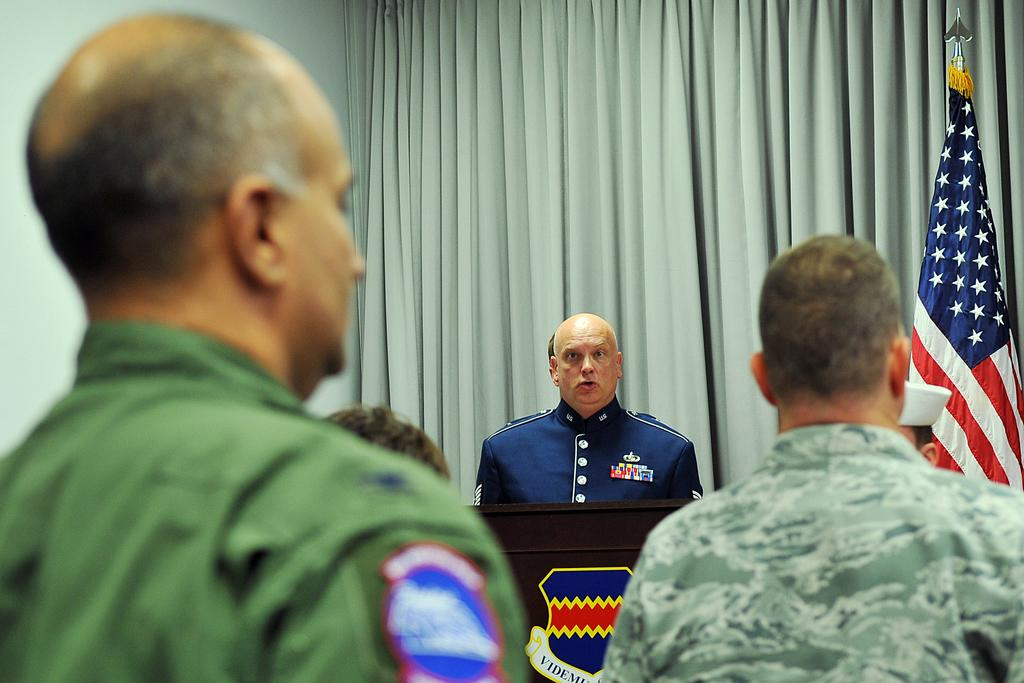What is happening in the image? There are people standing in the image. Can you describe the person in the background? There is a person standing near a podium in the background. What can be seen in the background besides the person? There is a curtain and a flag in the background. What type of offer is the person near the podium making to the cats in the image? There are no cats present in the image, and therefore no offer can be made to them. 